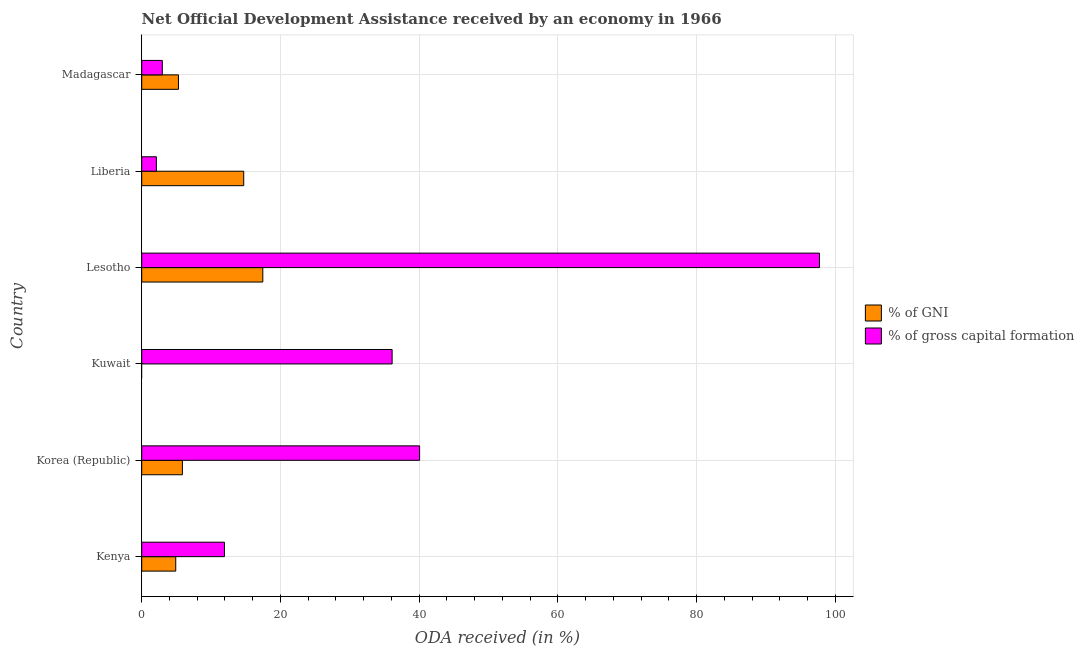How many different coloured bars are there?
Offer a very short reply. 2. Are the number of bars on each tick of the Y-axis equal?
Ensure brevity in your answer.  No. How many bars are there on the 5th tick from the top?
Your answer should be very brief. 2. What is the label of the 1st group of bars from the top?
Make the answer very short. Madagascar. In how many cases, is the number of bars for a given country not equal to the number of legend labels?
Make the answer very short. 1. Across all countries, what is the maximum oda received as percentage of gni?
Provide a short and direct response. 17.46. Across all countries, what is the minimum oda received as percentage of gni?
Your answer should be compact. 0. In which country was the oda received as percentage of gni maximum?
Your answer should be very brief. Lesotho. What is the total oda received as percentage of gni in the graph?
Ensure brevity in your answer.  48.24. What is the difference between the oda received as percentage of gross capital formation in Kenya and that in Lesotho?
Your answer should be compact. -85.8. What is the difference between the oda received as percentage of gni in Lesotho and the oda received as percentage of gross capital formation in Liberia?
Your response must be concise. 15.35. What is the average oda received as percentage of gross capital formation per country?
Offer a terse response. 31.82. What is the difference between the oda received as percentage of gross capital formation and oda received as percentage of gni in Liberia?
Offer a terse response. -12.59. What is the ratio of the oda received as percentage of gross capital formation in Korea (Republic) to that in Kuwait?
Ensure brevity in your answer.  1.11. Is the oda received as percentage of gni in Liberia less than that in Madagascar?
Ensure brevity in your answer.  No. Is the difference between the oda received as percentage of gross capital formation in Korea (Republic) and Madagascar greater than the difference between the oda received as percentage of gni in Korea (Republic) and Madagascar?
Your response must be concise. Yes. What is the difference between the highest and the second highest oda received as percentage of gni?
Your response must be concise. 2.75. What is the difference between the highest and the lowest oda received as percentage of gross capital formation?
Give a very brief answer. 95.61. Is the sum of the oda received as percentage of gni in Kenya and Korea (Republic) greater than the maximum oda received as percentage of gross capital formation across all countries?
Offer a terse response. No. Are all the bars in the graph horizontal?
Make the answer very short. Yes. How many countries are there in the graph?
Your answer should be very brief. 6. What is the difference between two consecutive major ticks on the X-axis?
Keep it short and to the point. 20. Are the values on the major ticks of X-axis written in scientific E-notation?
Your response must be concise. No. Does the graph contain grids?
Give a very brief answer. Yes. Where does the legend appear in the graph?
Provide a short and direct response. Center right. What is the title of the graph?
Offer a very short reply. Net Official Development Assistance received by an economy in 1966. Does "Old" appear as one of the legend labels in the graph?
Provide a succinct answer. No. What is the label or title of the X-axis?
Offer a very short reply. ODA received (in %). What is the ODA received (in %) in % of GNI in Kenya?
Provide a succinct answer. 4.9. What is the ODA received (in %) of % of gross capital formation in Kenya?
Offer a very short reply. 11.93. What is the ODA received (in %) in % of GNI in Korea (Republic)?
Give a very brief answer. 5.87. What is the ODA received (in %) of % of gross capital formation in Korea (Republic)?
Ensure brevity in your answer.  40.07. What is the ODA received (in %) in % of GNI in Kuwait?
Give a very brief answer. 0. What is the ODA received (in %) of % of gross capital formation in Kuwait?
Offer a very short reply. 36.11. What is the ODA received (in %) in % of GNI in Lesotho?
Your answer should be compact. 17.46. What is the ODA received (in %) of % of gross capital formation in Lesotho?
Your response must be concise. 97.73. What is the ODA received (in %) in % of GNI in Liberia?
Your response must be concise. 14.71. What is the ODA received (in %) of % of gross capital formation in Liberia?
Give a very brief answer. 2.11. What is the ODA received (in %) in % of GNI in Madagascar?
Provide a succinct answer. 5.3. What is the ODA received (in %) in % of gross capital formation in Madagascar?
Provide a succinct answer. 2.97. Across all countries, what is the maximum ODA received (in %) in % of GNI?
Your answer should be very brief. 17.46. Across all countries, what is the maximum ODA received (in %) of % of gross capital formation?
Your response must be concise. 97.73. Across all countries, what is the minimum ODA received (in %) in % of GNI?
Provide a short and direct response. 0. Across all countries, what is the minimum ODA received (in %) in % of gross capital formation?
Keep it short and to the point. 2.11. What is the total ODA received (in %) of % of GNI in the graph?
Your answer should be compact. 48.24. What is the total ODA received (in %) of % of gross capital formation in the graph?
Ensure brevity in your answer.  190.92. What is the difference between the ODA received (in %) of % of GNI in Kenya and that in Korea (Republic)?
Provide a succinct answer. -0.96. What is the difference between the ODA received (in %) in % of gross capital formation in Kenya and that in Korea (Republic)?
Ensure brevity in your answer.  -28.14. What is the difference between the ODA received (in %) in % of gross capital formation in Kenya and that in Kuwait?
Provide a succinct answer. -24.18. What is the difference between the ODA received (in %) in % of GNI in Kenya and that in Lesotho?
Your response must be concise. -12.56. What is the difference between the ODA received (in %) in % of gross capital formation in Kenya and that in Lesotho?
Your response must be concise. -85.8. What is the difference between the ODA received (in %) in % of GNI in Kenya and that in Liberia?
Make the answer very short. -9.8. What is the difference between the ODA received (in %) of % of gross capital formation in Kenya and that in Liberia?
Provide a short and direct response. 9.81. What is the difference between the ODA received (in %) of % of GNI in Kenya and that in Madagascar?
Your answer should be very brief. -0.4. What is the difference between the ODA received (in %) in % of gross capital formation in Kenya and that in Madagascar?
Provide a short and direct response. 8.96. What is the difference between the ODA received (in %) of % of gross capital formation in Korea (Republic) and that in Kuwait?
Your response must be concise. 3.97. What is the difference between the ODA received (in %) in % of GNI in Korea (Republic) and that in Lesotho?
Provide a short and direct response. -11.6. What is the difference between the ODA received (in %) of % of gross capital formation in Korea (Republic) and that in Lesotho?
Provide a succinct answer. -57.66. What is the difference between the ODA received (in %) in % of GNI in Korea (Republic) and that in Liberia?
Offer a terse response. -8.84. What is the difference between the ODA received (in %) of % of gross capital formation in Korea (Republic) and that in Liberia?
Your response must be concise. 37.96. What is the difference between the ODA received (in %) of % of GNI in Korea (Republic) and that in Madagascar?
Give a very brief answer. 0.57. What is the difference between the ODA received (in %) of % of gross capital formation in Korea (Republic) and that in Madagascar?
Give a very brief answer. 37.1. What is the difference between the ODA received (in %) in % of gross capital formation in Kuwait and that in Lesotho?
Offer a very short reply. -61.62. What is the difference between the ODA received (in %) of % of gross capital formation in Kuwait and that in Liberia?
Your answer should be very brief. 33.99. What is the difference between the ODA received (in %) in % of gross capital formation in Kuwait and that in Madagascar?
Keep it short and to the point. 33.14. What is the difference between the ODA received (in %) in % of GNI in Lesotho and that in Liberia?
Ensure brevity in your answer.  2.75. What is the difference between the ODA received (in %) of % of gross capital formation in Lesotho and that in Liberia?
Make the answer very short. 95.61. What is the difference between the ODA received (in %) of % of GNI in Lesotho and that in Madagascar?
Your response must be concise. 12.16. What is the difference between the ODA received (in %) in % of gross capital formation in Lesotho and that in Madagascar?
Your response must be concise. 94.76. What is the difference between the ODA received (in %) of % of GNI in Liberia and that in Madagascar?
Make the answer very short. 9.41. What is the difference between the ODA received (in %) in % of gross capital formation in Liberia and that in Madagascar?
Offer a very short reply. -0.85. What is the difference between the ODA received (in %) in % of GNI in Kenya and the ODA received (in %) in % of gross capital formation in Korea (Republic)?
Your answer should be compact. -35.17. What is the difference between the ODA received (in %) in % of GNI in Kenya and the ODA received (in %) in % of gross capital formation in Kuwait?
Offer a terse response. -31.2. What is the difference between the ODA received (in %) of % of GNI in Kenya and the ODA received (in %) of % of gross capital formation in Lesotho?
Offer a very short reply. -92.82. What is the difference between the ODA received (in %) in % of GNI in Kenya and the ODA received (in %) in % of gross capital formation in Liberia?
Give a very brief answer. 2.79. What is the difference between the ODA received (in %) in % of GNI in Kenya and the ODA received (in %) in % of gross capital formation in Madagascar?
Offer a terse response. 1.93. What is the difference between the ODA received (in %) in % of GNI in Korea (Republic) and the ODA received (in %) in % of gross capital formation in Kuwait?
Keep it short and to the point. -30.24. What is the difference between the ODA received (in %) of % of GNI in Korea (Republic) and the ODA received (in %) of % of gross capital formation in Lesotho?
Provide a succinct answer. -91.86. What is the difference between the ODA received (in %) in % of GNI in Korea (Republic) and the ODA received (in %) in % of gross capital formation in Liberia?
Your answer should be very brief. 3.75. What is the difference between the ODA received (in %) in % of GNI in Korea (Republic) and the ODA received (in %) in % of gross capital formation in Madagascar?
Offer a terse response. 2.9. What is the difference between the ODA received (in %) in % of GNI in Lesotho and the ODA received (in %) in % of gross capital formation in Liberia?
Make the answer very short. 15.35. What is the difference between the ODA received (in %) of % of GNI in Lesotho and the ODA received (in %) of % of gross capital formation in Madagascar?
Offer a terse response. 14.49. What is the difference between the ODA received (in %) of % of GNI in Liberia and the ODA received (in %) of % of gross capital formation in Madagascar?
Your answer should be compact. 11.74. What is the average ODA received (in %) of % of GNI per country?
Your answer should be very brief. 8.04. What is the average ODA received (in %) of % of gross capital formation per country?
Make the answer very short. 31.82. What is the difference between the ODA received (in %) in % of GNI and ODA received (in %) in % of gross capital formation in Kenya?
Make the answer very short. -7.03. What is the difference between the ODA received (in %) in % of GNI and ODA received (in %) in % of gross capital formation in Korea (Republic)?
Keep it short and to the point. -34.21. What is the difference between the ODA received (in %) of % of GNI and ODA received (in %) of % of gross capital formation in Lesotho?
Your answer should be very brief. -80.27. What is the difference between the ODA received (in %) of % of GNI and ODA received (in %) of % of gross capital formation in Liberia?
Your response must be concise. 12.59. What is the difference between the ODA received (in %) in % of GNI and ODA received (in %) in % of gross capital formation in Madagascar?
Provide a succinct answer. 2.33. What is the ratio of the ODA received (in %) of % of GNI in Kenya to that in Korea (Republic)?
Offer a very short reply. 0.84. What is the ratio of the ODA received (in %) of % of gross capital formation in Kenya to that in Korea (Republic)?
Make the answer very short. 0.3. What is the ratio of the ODA received (in %) of % of gross capital formation in Kenya to that in Kuwait?
Offer a very short reply. 0.33. What is the ratio of the ODA received (in %) of % of GNI in Kenya to that in Lesotho?
Your answer should be very brief. 0.28. What is the ratio of the ODA received (in %) of % of gross capital formation in Kenya to that in Lesotho?
Your answer should be very brief. 0.12. What is the ratio of the ODA received (in %) in % of GNI in Kenya to that in Liberia?
Keep it short and to the point. 0.33. What is the ratio of the ODA received (in %) in % of gross capital formation in Kenya to that in Liberia?
Ensure brevity in your answer.  5.64. What is the ratio of the ODA received (in %) in % of GNI in Kenya to that in Madagascar?
Keep it short and to the point. 0.93. What is the ratio of the ODA received (in %) in % of gross capital formation in Kenya to that in Madagascar?
Give a very brief answer. 4.02. What is the ratio of the ODA received (in %) of % of gross capital formation in Korea (Republic) to that in Kuwait?
Make the answer very short. 1.11. What is the ratio of the ODA received (in %) in % of GNI in Korea (Republic) to that in Lesotho?
Offer a terse response. 0.34. What is the ratio of the ODA received (in %) in % of gross capital formation in Korea (Republic) to that in Lesotho?
Make the answer very short. 0.41. What is the ratio of the ODA received (in %) in % of GNI in Korea (Republic) to that in Liberia?
Keep it short and to the point. 0.4. What is the ratio of the ODA received (in %) of % of gross capital formation in Korea (Republic) to that in Liberia?
Offer a very short reply. 18.95. What is the ratio of the ODA received (in %) of % of GNI in Korea (Republic) to that in Madagascar?
Keep it short and to the point. 1.11. What is the ratio of the ODA received (in %) of % of gross capital formation in Korea (Republic) to that in Madagascar?
Provide a short and direct response. 13.5. What is the ratio of the ODA received (in %) of % of gross capital formation in Kuwait to that in Lesotho?
Provide a succinct answer. 0.37. What is the ratio of the ODA received (in %) of % of gross capital formation in Kuwait to that in Liberia?
Your answer should be very brief. 17.08. What is the ratio of the ODA received (in %) in % of gross capital formation in Kuwait to that in Madagascar?
Make the answer very short. 12.16. What is the ratio of the ODA received (in %) of % of GNI in Lesotho to that in Liberia?
Keep it short and to the point. 1.19. What is the ratio of the ODA received (in %) of % of gross capital formation in Lesotho to that in Liberia?
Your answer should be very brief. 46.22. What is the ratio of the ODA received (in %) of % of GNI in Lesotho to that in Madagascar?
Keep it short and to the point. 3.3. What is the ratio of the ODA received (in %) in % of gross capital formation in Lesotho to that in Madagascar?
Offer a terse response. 32.92. What is the ratio of the ODA received (in %) in % of GNI in Liberia to that in Madagascar?
Give a very brief answer. 2.78. What is the ratio of the ODA received (in %) of % of gross capital formation in Liberia to that in Madagascar?
Keep it short and to the point. 0.71. What is the difference between the highest and the second highest ODA received (in %) of % of GNI?
Keep it short and to the point. 2.75. What is the difference between the highest and the second highest ODA received (in %) of % of gross capital formation?
Your answer should be compact. 57.66. What is the difference between the highest and the lowest ODA received (in %) of % of GNI?
Provide a succinct answer. 17.46. What is the difference between the highest and the lowest ODA received (in %) of % of gross capital formation?
Keep it short and to the point. 95.61. 